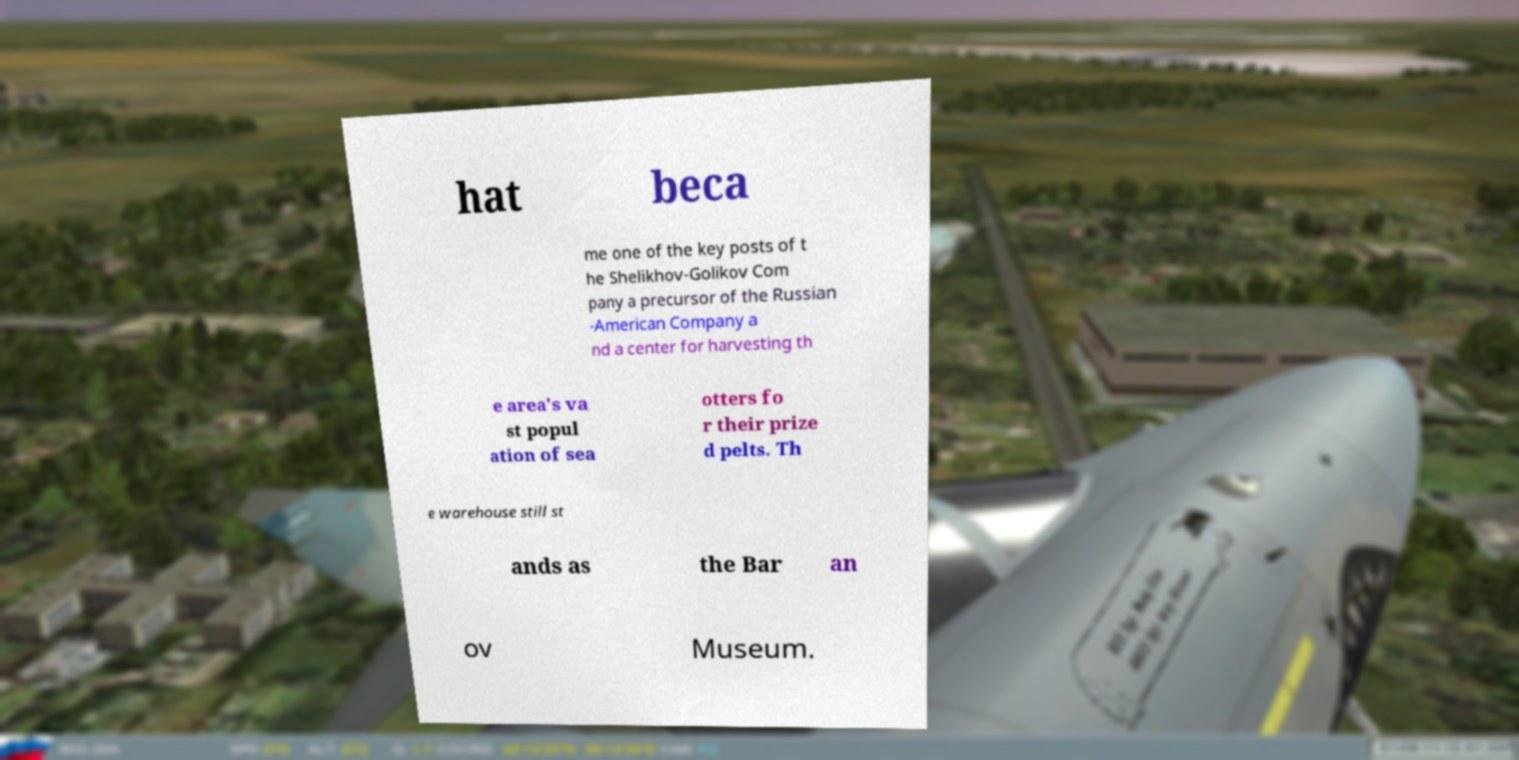For documentation purposes, I need the text within this image transcribed. Could you provide that? hat beca me one of the key posts of t he Shelikhov-Golikov Com pany a precursor of the Russian -American Company a nd a center for harvesting th e area's va st popul ation of sea otters fo r their prize d pelts. Th e warehouse still st ands as the Bar an ov Museum. 